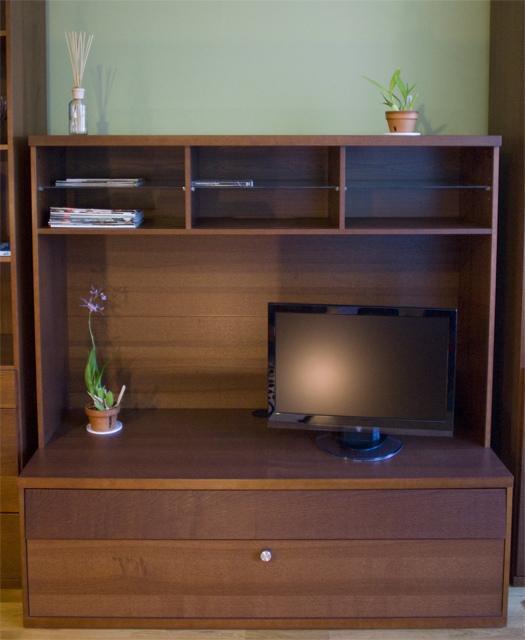How many plants are in the picture?
Give a very brief answer. 2. How many drawers are shown?
Give a very brief answer. 1. 